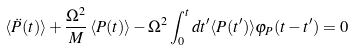<formula> <loc_0><loc_0><loc_500><loc_500>\langle \ddot { P } ( t ) \rangle + \frac { \Omega ^ { 2 } } { M } \, \langle P ( t ) \rangle - \Omega ^ { 2 } \int _ { 0 } ^ { t } d t ^ { \prime } \langle { P } ( t ^ { \prime } ) \rangle \varphi _ { P } ( t - t ^ { \prime } ) = 0</formula> 